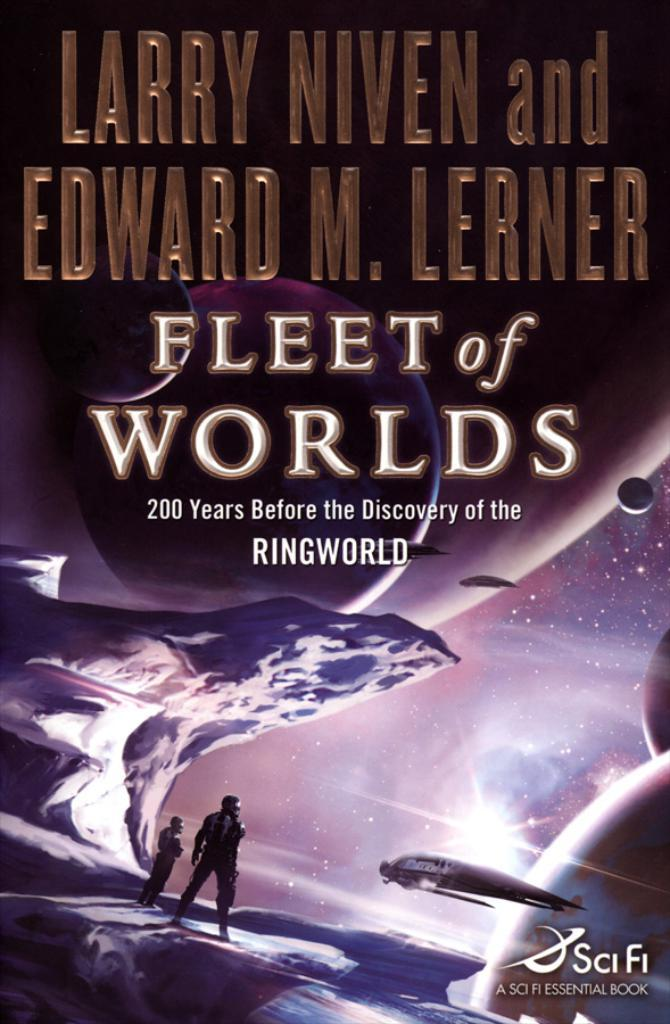Provide a one-sentence caption for the provided image. The front cover of a book called Fleet of Worlds. 